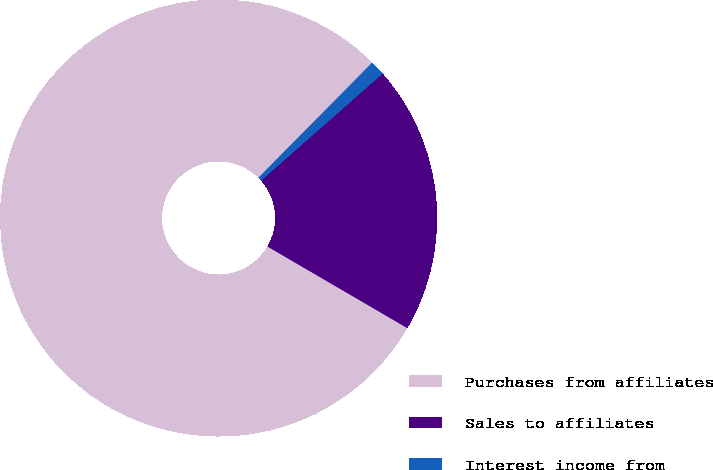Convert chart. <chart><loc_0><loc_0><loc_500><loc_500><pie_chart><fcel>Purchases from affiliates<fcel>Sales to affiliates<fcel>Interest income from<nl><fcel>79.01%<fcel>19.89%<fcel>1.1%<nl></chart> 